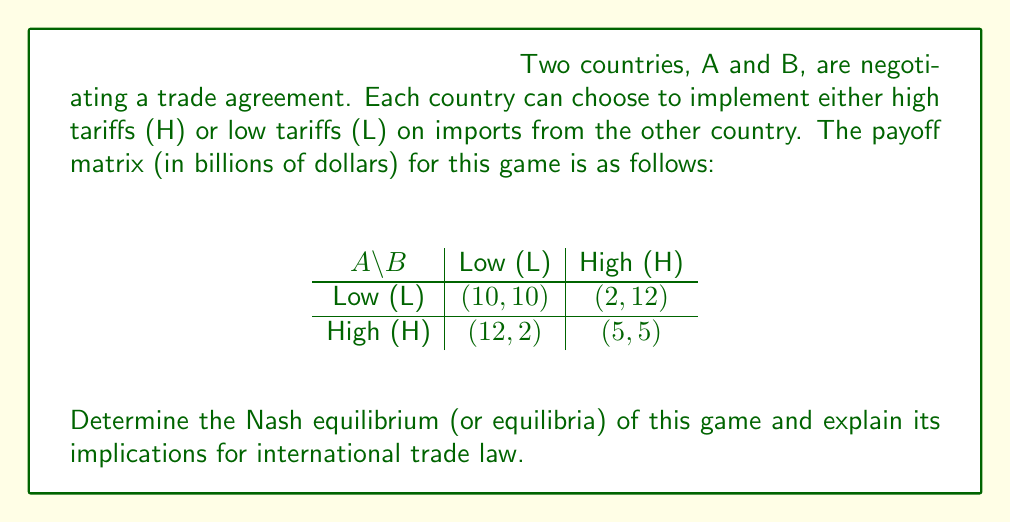Give your solution to this math problem. To solve this problem, we need to analyze the strategic choices of both countries and find the Nash equilibrium. A Nash equilibrium is a situation where no player can unilaterally improve their outcome by changing their strategy.

Step 1: Analyze Country A's best responses
- If B chooses L, A's best response is H (12 > 10)
- If B chooses H, A's best response is H (5 > 2)

Step 2: Analyze Country B's best responses
- If A chooses L, B's best response is H (12 > 10)
- If A chooses H, B's best response is H (5 > 2)

Step 3: Identify the Nash equilibrium
The Nash equilibrium occurs where both countries' best responses intersect. In this case, it's when both countries choose High tariffs (H, H), resulting in payoffs of (5, 5).

Step 4: Interpret the results
This game represents a classic Prisoner's Dilemma in international trade. The Nash equilibrium (H, H) is not Pareto optimal, as both countries would be better off if they both chose Low tariffs (L, L), which would result in payoffs of (10, 10).

Implications for international trade law:
1. The Nash equilibrium demonstrates the natural tendency of countries to implement protectionist policies (high tariffs) in the absence of binding agreements.
2. This outcome highlights the importance of international trade organizations and agreements (e.g., WTO) in facilitating cooperation and preventing trade wars.
3. Domestic trade laws should be designed to align with international agreements that promote lower tariffs and free trade, as this can lead to better outcomes for all parties involved.
4. The game illustrates the need for enforcement mechanisms in international trade law to ensure countries adhere to their commitments and avoid defecting to high tariff strategies.
Answer: The Nash equilibrium of this game is (H, H), where both countries choose High tariffs, resulting in payoffs of (5, 5). This equilibrium demonstrates the tendency towards protectionist policies in international trade and underscores the importance of binding agreements and international organizations in promoting cooperation and free trade. 